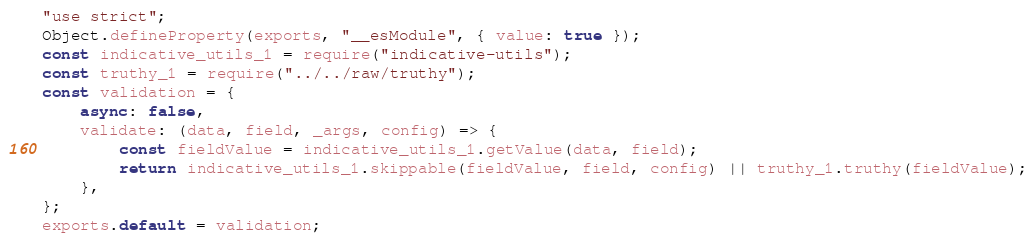Convert code to text. <code><loc_0><loc_0><loc_500><loc_500><_JavaScript_>"use strict";
Object.defineProperty(exports, "__esModule", { value: true });
const indicative_utils_1 = require("indicative-utils");
const truthy_1 = require("../../raw/truthy");
const validation = {
    async: false,
    validate: (data, field, _args, config) => {
        const fieldValue = indicative_utils_1.getValue(data, field);
        return indicative_utils_1.skippable(fieldValue, field, config) || truthy_1.truthy(fieldValue);
    },
};
exports.default = validation;
</code> 